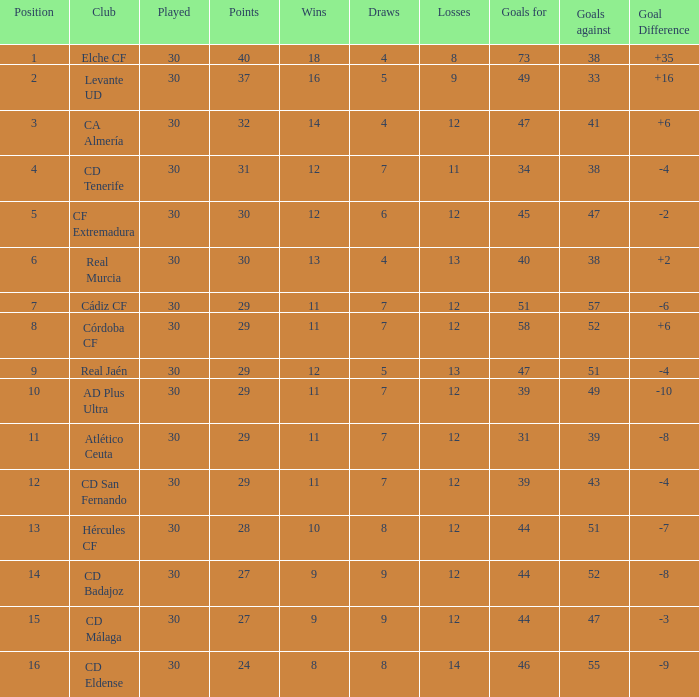Determine the combined number of goals with less than 30 points, a spot outside the top 10, and more than 57 goals against. None. 